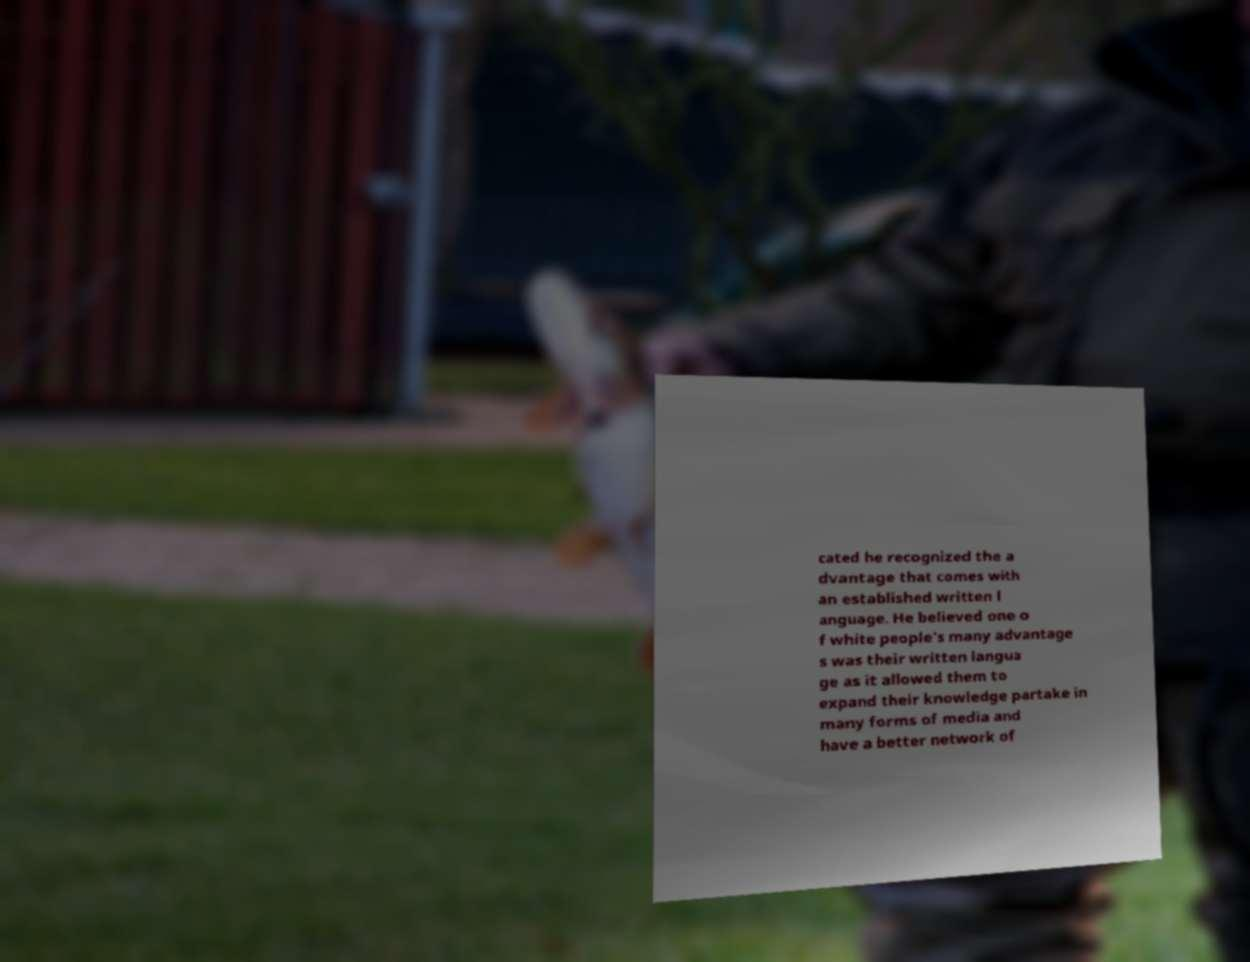Please identify and transcribe the text found in this image. cated he recognized the a dvantage that comes with an established written l anguage. He believed one o f white people's many advantage s was their written langua ge as it allowed them to expand their knowledge partake in many forms of media and have a better network of 